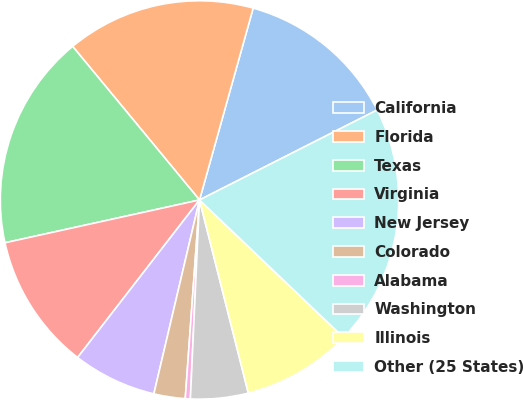Convert chart. <chart><loc_0><loc_0><loc_500><loc_500><pie_chart><fcel>California<fcel>Florida<fcel>Texas<fcel>Virginia<fcel>New Jersey<fcel>Colorado<fcel>Alabama<fcel>Washington<fcel>Illinois<fcel>Other (25 States)<nl><fcel>13.2%<fcel>15.33%<fcel>17.46%<fcel>11.07%<fcel>6.8%<fcel>2.54%<fcel>0.41%<fcel>4.67%<fcel>8.93%<fcel>19.59%<nl></chart> 